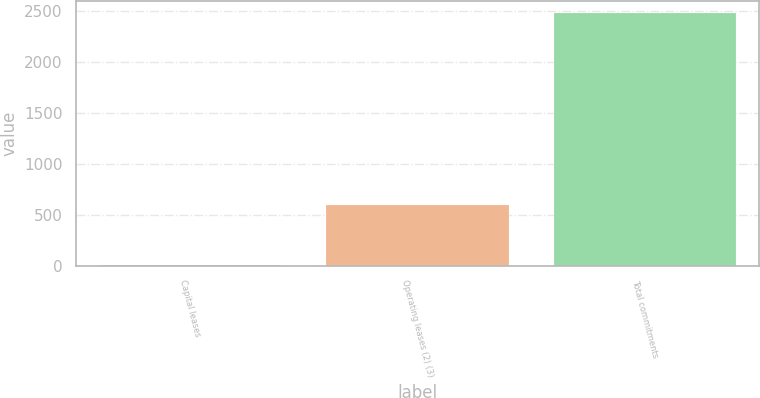Convert chart to OTSL. <chart><loc_0><loc_0><loc_500><loc_500><bar_chart><fcel>Capital leases<fcel>Operating leases (2) (3)<fcel>Total commitments<nl><fcel>7<fcel>595<fcel>2475<nl></chart> 